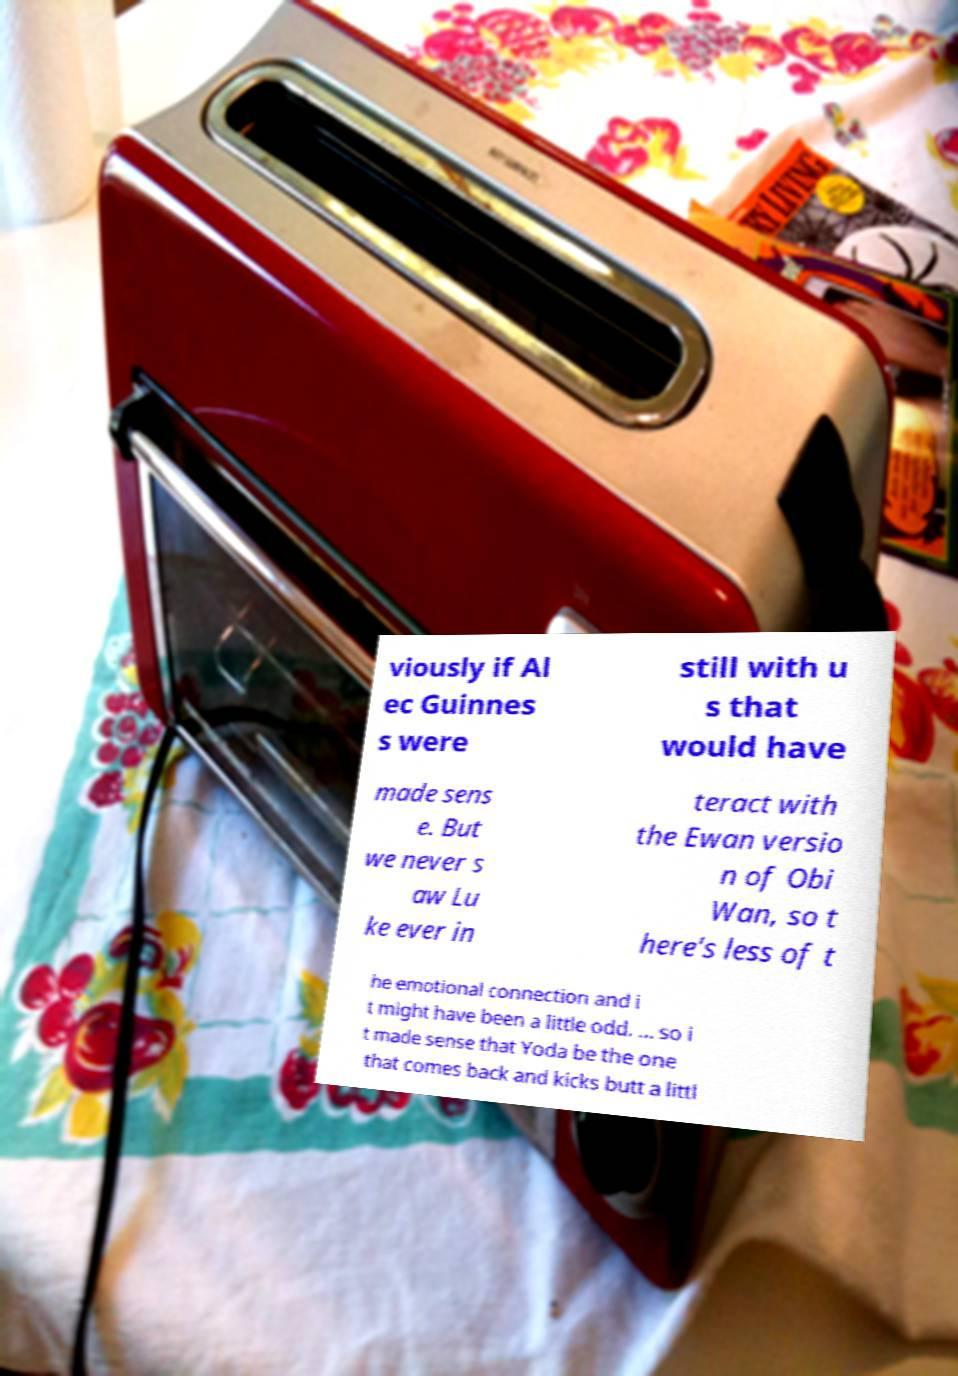For documentation purposes, I need the text within this image transcribed. Could you provide that? viously if Al ec Guinnes s were still with u s that would have made sens e. But we never s aw Lu ke ever in teract with the Ewan versio n of Obi Wan, so t here's less of t he emotional connection and i t might have been a little odd. ... so i t made sense that Yoda be the one that comes back and kicks butt a littl 